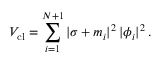Convert formula to latex. <formula><loc_0><loc_0><loc_500><loc_500>V _ { c l } = \sum _ { i = 1 } ^ { N + 1 } | \sigma + m _ { i } | ^ { 2 } \, | \phi _ { i } | ^ { 2 } \, .</formula> 